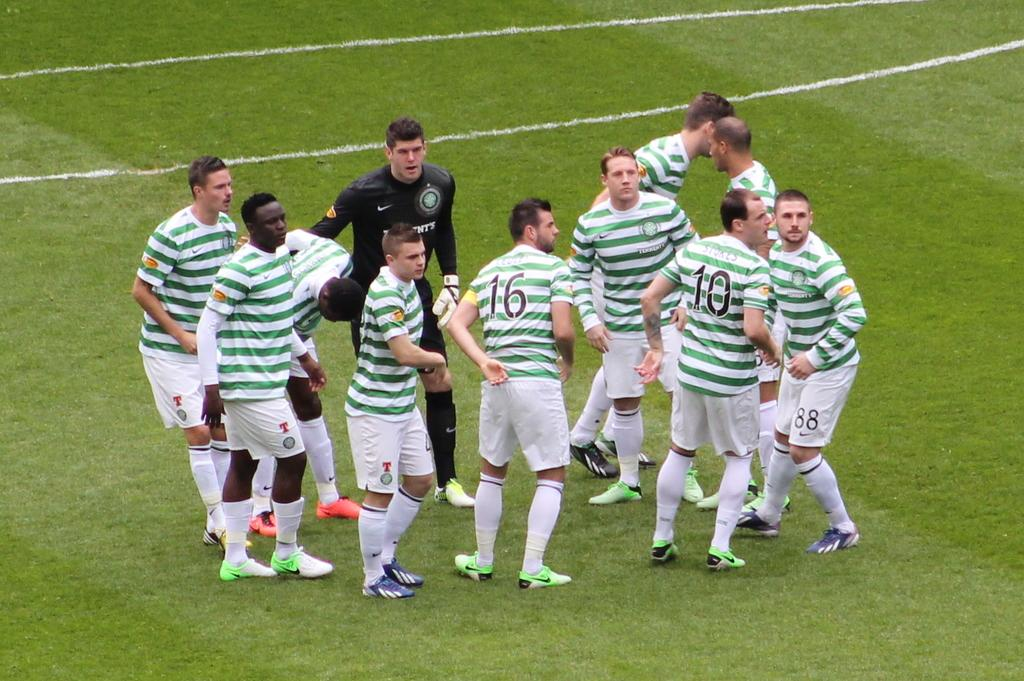Provide a one-sentence caption for the provided image. A sports team wears white and green striped uniforms and number 16 it looking to the right. 